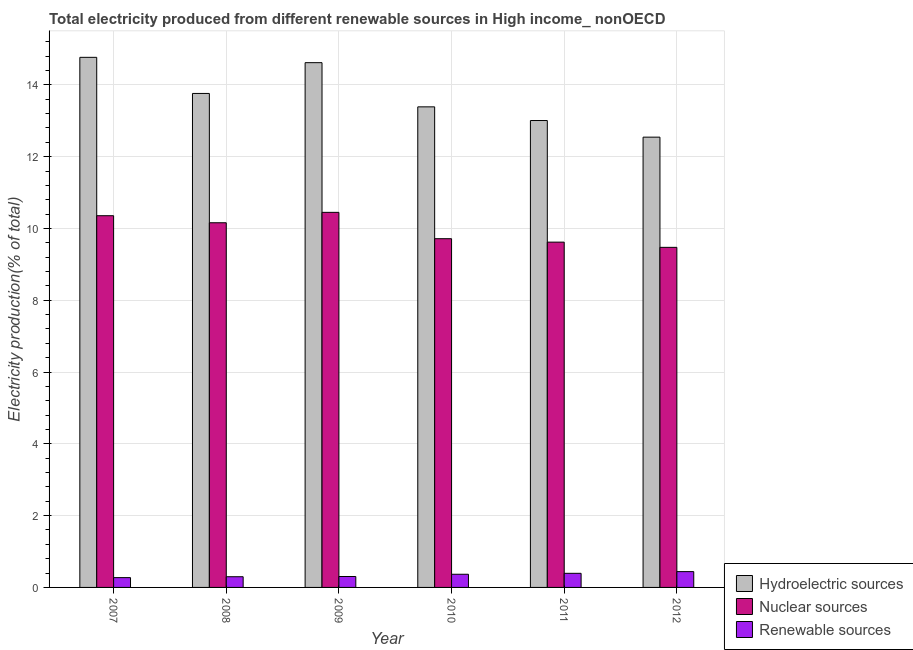How many different coloured bars are there?
Give a very brief answer. 3. How many groups of bars are there?
Provide a succinct answer. 6. Are the number of bars per tick equal to the number of legend labels?
Provide a short and direct response. Yes. How many bars are there on the 6th tick from the right?
Provide a short and direct response. 3. What is the label of the 6th group of bars from the left?
Offer a very short reply. 2012. In how many cases, is the number of bars for a given year not equal to the number of legend labels?
Provide a short and direct response. 0. What is the percentage of electricity produced by hydroelectric sources in 2012?
Offer a terse response. 12.54. Across all years, what is the maximum percentage of electricity produced by hydroelectric sources?
Offer a very short reply. 14.77. Across all years, what is the minimum percentage of electricity produced by nuclear sources?
Ensure brevity in your answer.  9.47. In which year was the percentage of electricity produced by hydroelectric sources minimum?
Ensure brevity in your answer.  2012. What is the total percentage of electricity produced by hydroelectric sources in the graph?
Provide a short and direct response. 82.09. What is the difference between the percentage of electricity produced by renewable sources in 2008 and that in 2009?
Your response must be concise. -0.01. What is the difference between the percentage of electricity produced by hydroelectric sources in 2007 and the percentage of electricity produced by renewable sources in 2009?
Your answer should be very brief. 0.15. What is the average percentage of electricity produced by nuclear sources per year?
Your answer should be very brief. 9.96. What is the ratio of the percentage of electricity produced by hydroelectric sources in 2009 to that in 2012?
Offer a very short reply. 1.17. Is the percentage of electricity produced by nuclear sources in 2009 less than that in 2011?
Make the answer very short. No. Is the difference between the percentage of electricity produced by renewable sources in 2008 and 2010 greater than the difference between the percentage of electricity produced by hydroelectric sources in 2008 and 2010?
Provide a short and direct response. No. What is the difference between the highest and the second highest percentage of electricity produced by hydroelectric sources?
Offer a very short reply. 0.15. What is the difference between the highest and the lowest percentage of electricity produced by nuclear sources?
Your response must be concise. 0.97. What does the 1st bar from the left in 2009 represents?
Give a very brief answer. Hydroelectric sources. What does the 1st bar from the right in 2012 represents?
Make the answer very short. Renewable sources. How many bars are there?
Provide a succinct answer. 18. Are the values on the major ticks of Y-axis written in scientific E-notation?
Your answer should be compact. No. How many legend labels are there?
Provide a succinct answer. 3. What is the title of the graph?
Your answer should be compact. Total electricity produced from different renewable sources in High income_ nonOECD. What is the label or title of the X-axis?
Give a very brief answer. Year. What is the label or title of the Y-axis?
Keep it short and to the point. Electricity production(% of total). What is the Electricity production(% of total) in Hydroelectric sources in 2007?
Provide a succinct answer. 14.77. What is the Electricity production(% of total) in Nuclear sources in 2007?
Your response must be concise. 10.36. What is the Electricity production(% of total) of Renewable sources in 2007?
Offer a very short reply. 0.27. What is the Electricity production(% of total) in Hydroelectric sources in 2008?
Give a very brief answer. 13.76. What is the Electricity production(% of total) in Nuclear sources in 2008?
Keep it short and to the point. 10.16. What is the Electricity production(% of total) of Renewable sources in 2008?
Offer a very short reply. 0.3. What is the Electricity production(% of total) of Hydroelectric sources in 2009?
Your answer should be compact. 14.62. What is the Electricity production(% of total) in Nuclear sources in 2009?
Provide a short and direct response. 10.45. What is the Electricity production(% of total) in Renewable sources in 2009?
Provide a short and direct response. 0.3. What is the Electricity production(% of total) of Hydroelectric sources in 2010?
Offer a very short reply. 13.39. What is the Electricity production(% of total) of Nuclear sources in 2010?
Provide a short and direct response. 9.71. What is the Electricity production(% of total) in Renewable sources in 2010?
Make the answer very short. 0.37. What is the Electricity production(% of total) of Hydroelectric sources in 2011?
Keep it short and to the point. 13.01. What is the Electricity production(% of total) in Nuclear sources in 2011?
Keep it short and to the point. 9.62. What is the Electricity production(% of total) of Renewable sources in 2011?
Provide a succinct answer. 0.39. What is the Electricity production(% of total) of Hydroelectric sources in 2012?
Keep it short and to the point. 12.54. What is the Electricity production(% of total) in Nuclear sources in 2012?
Offer a terse response. 9.47. What is the Electricity production(% of total) in Renewable sources in 2012?
Provide a short and direct response. 0.44. Across all years, what is the maximum Electricity production(% of total) of Hydroelectric sources?
Provide a succinct answer. 14.77. Across all years, what is the maximum Electricity production(% of total) of Nuclear sources?
Provide a succinct answer. 10.45. Across all years, what is the maximum Electricity production(% of total) in Renewable sources?
Offer a terse response. 0.44. Across all years, what is the minimum Electricity production(% of total) in Hydroelectric sources?
Your answer should be compact. 12.54. Across all years, what is the minimum Electricity production(% of total) of Nuclear sources?
Your answer should be very brief. 9.47. Across all years, what is the minimum Electricity production(% of total) of Renewable sources?
Offer a very short reply. 0.27. What is the total Electricity production(% of total) in Hydroelectric sources in the graph?
Your answer should be very brief. 82.09. What is the total Electricity production(% of total) of Nuclear sources in the graph?
Provide a short and direct response. 59.77. What is the total Electricity production(% of total) in Renewable sources in the graph?
Offer a terse response. 2.08. What is the difference between the Electricity production(% of total) of Hydroelectric sources in 2007 and that in 2008?
Ensure brevity in your answer.  1.01. What is the difference between the Electricity production(% of total) in Nuclear sources in 2007 and that in 2008?
Keep it short and to the point. 0.2. What is the difference between the Electricity production(% of total) of Renewable sources in 2007 and that in 2008?
Ensure brevity in your answer.  -0.02. What is the difference between the Electricity production(% of total) in Hydroelectric sources in 2007 and that in 2009?
Your response must be concise. 0.15. What is the difference between the Electricity production(% of total) in Nuclear sources in 2007 and that in 2009?
Provide a succinct answer. -0.09. What is the difference between the Electricity production(% of total) of Renewable sources in 2007 and that in 2009?
Make the answer very short. -0.03. What is the difference between the Electricity production(% of total) in Hydroelectric sources in 2007 and that in 2010?
Your response must be concise. 1.38. What is the difference between the Electricity production(% of total) of Nuclear sources in 2007 and that in 2010?
Give a very brief answer. 0.64. What is the difference between the Electricity production(% of total) in Renewable sources in 2007 and that in 2010?
Make the answer very short. -0.09. What is the difference between the Electricity production(% of total) in Hydroelectric sources in 2007 and that in 2011?
Make the answer very short. 1.76. What is the difference between the Electricity production(% of total) of Nuclear sources in 2007 and that in 2011?
Provide a succinct answer. 0.74. What is the difference between the Electricity production(% of total) of Renewable sources in 2007 and that in 2011?
Your response must be concise. -0.12. What is the difference between the Electricity production(% of total) in Hydroelectric sources in 2007 and that in 2012?
Give a very brief answer. 2.22. What is the difference between the Electricity production(% of total) of Nuclear sources in 2007 and that in 2012?
Your answer should be very brief. 0.88. What is the difference between the Electricity production(% of total) of Renewable sources in 2007 and that in 2012?
Make the answer very short. -0.17. What is the difference between the Electricity production(% of total) in Hydroelectric sources in 2008 and that in 2009?
Your response must be concise. -0.86. What is the difference between the Electricity production(% of total) in Nuclear sources in 2008 and that in 2009?
Keep it short and to the point. -0.29. What is the difference between the Electricity production(% of total) in Renewable sources in 2008 and that in 2009?
Ensure brevity in your answer.  -0.01. What is the difference between the Electricity production(% of total) of Hydroelectric sources in 2008 and that in 2010?
Make the answer very short. 0.37. What is the difference between the Electricity production(% of total) in Nuclear sources in 2008 and that in 2010?
Your answer should be very brief. 0.44. What is the difference between the Electricity production(% of total) in Renewable sources in 2008 and that in 2010?
Offer a very short reply. -0.07. What is the difference between the Electricity production(% of total) in Hydroelectric sources in 2008 and that in 2011?
Offer a terse response. 0.75. What is the difference between the Electricity production(% of total) of Nuclear sources in 2008 and that in 2011?
Your response must be concise. 0.54. What is the difference between the Electricity production(% of total) in Renewable sources in 2008 and that in 2011?
Provide a succinct answer. -0.09. What is the difference between the Electricity production(% of total) in Hydroelectric sources in 2008 and that in 2012?
Ensure brevity in your answer.  1.22. What is the difference between the Electricity production(% of total) in Nuclear sources in 2008 and that in 2012?
Your answer should be compact. 0.69. What is the difference between the Electricity production(% of total) of Renewable sources in 2008 and that in 2012?
Your answer should be very brief. -0.14. What is the difference between the Electricity production(% of total) of Hydroelectric sources in 2009 and that in 2010?
Provide a succinct answer. 1.23. What is the difference between the Electricity production(% of total) in Nuclear sources in 2009 and that in 2010?
Give a very brief answer. 0.73. What is the difference between the Electricity production(% of total) in Renewable sources in 2009 and that in 2010?
Provide a succinct answer. -0.06. What is the difference between the Electricity production(% of total) in Hydroelectric sources in 2009 and that in 2011?
Your answer should be compact. 1.61. What is the difference between the Electricity production(% of total) of Nuclear sources in 2009 and that in 2011?
Your response must be concise. 0.83. What is the difference between the Electricity production(% of total) of Renewable sources in 2009 and that in 2011?
Offer a very short reply. -0.09. What is the difference between the Electricity production(% of total) in Hydroelectric sources in 2009 and that in 2012?
Offer a terse response. 2.08. What is the difference between the Electricity production(% of total) of Renewable sources in 2009 and that in 2012?
Give a very brief answer. -0.14. What is the difference between the Electricity production(% of total) in Hydroelectric sources in 2010 and that in 2011?
Your response must be concise. 0.38. What is the difference between the Electricity production(% of total) of Nuclear sources in 2010 and that in 2011?
Your response must be concise. 0.1. What is the difference between the Electricity production(% of total) of Renewable sources in 2010 and that in 2011?
Keep it short and to the point. -0.03. What is the difference between the Electricity production(% of total) in Hydroelectric sources in 2010 and that in 2012?
Give a very brief answer. 0.84. What is the difference between the Electricity production(% of total) in Nuclear sources in 2010 and that in 2012?
Offer a very short reply. 0.24. What is the difference between the Electricity production(% of total) in Renewable sources in 2010 and that in 2012?
Ensure brevity in your answer.  -0.07. What is the difference between the Electricity production(% of total) in Hydroelectric sources in 2011 and that in 2012?
Make the answer very short. 0.46. What is the difference between the Electricity production(% of total) of Nuclear sources in 2011 and that in 2012?
Your answer should be very brief. 0.15. What is the difference between the Electricity production(% of total) of Renewable sources in 2011 and that in 2012?
Your answer should be very brief. -0.05. What is the difference between the Electricity production(% of total) in Hydroelectric sources in 2007 and the Electricity production(% of total) in Nuclear sources in 2008?
Provide a short and direct response. 4.61. What is the difference between the Electricity production(% of total) in Hydroelectric sources in 2007 and the Electricity production(% of total) in Renewable sources in 2008?
Your answer should be very brief. 14.47. What is the difference between the Electricity production(% of total) of Nuclear sources in 2007 and the Electricity production(% of total) of Renewable sources in 2008?
Give a very brief answer. 10.06. What is the difference between the Electricity production(% of total) in Hydroelectric sources in 2007 and the Electricity production(% of total) in Nuclear sources in 2009?
Ensure brevity in your answer.  4.32. What is the difference between the Electricity production(% of total) of Hydroelectric sources in 2007 and the Electricity production(% of total) of Renewable sources in 2009?
Your answer should be compact. 14.46. What is the difference between the Electricity production(% of total) in Nuclear sources in 2007 and the Electricity production(% of total) in Renewable sources in 2009?
Provide a succinct answer. 10.05. What is the difference between the Electricity production(% of total) in Hydroelectric sources in 2007 and the Electricity production(% of total) in Nuclear sources in 2010?
Your answer should be compact. 5.05. What is the difference between the Electricity production(% of total) of Hydroelectric sources in 2007 and the Electricity production(% of total) of Renewable sources in 2010?
Your answer should be compact. 14.4. What is the difference between the Electricity production(% of total) of Nuclear sources in 2007 and the Electricity production(% of total) of Renewable sources in 2010?
Your response must be concise. 9.99. What is the difference between the Electricity production(% of total) of Hydroelectric sources in 2007 and the Electricity production(% of total) of Nuclear sources in 2011?
Provide a succinct answer. 5.15. What is the difference between the Electricity production(% of total) in Hydroelectric sources in 2007 and the Electricity production(% of total) in Renewable sources in 2011?
Make the answer very short. 14.37. What is the difference between the Electricity production(% of total) in Nuclear sources in 2007 and the Electricity production(% of total) in Renewable sources in 2011?
Provide a succinct answer. 9.96. What is the difference between the Electricity production(% of total) of Hydroelectric sources in 2007 and the Electricity production(% of total) of Nuclear sources in 2012?
Give a very brief answer. 5.29. What is the difference between the Electricity production(% of total) in Hydroelectric sources in 2007 and the Electricity production(% of total) in Renewable sources in 2012?
Keep it short and to the point. 14.33. What is the difference between the Electricity production(% of total) of Nuclear sources in 2007 and the Electricity production(% of total) of Renewable sources in 2012?
Ensure brevity in your answer.  9.91. What is the difference between the Electricity production(% of total) in Hydroelectric sources in 2008 and the Electricity production(% of total) in Nuclear sources in 2009?
Offer a very short reply. 3.31. What is the difference between the Electricity production(% of total) in Hydroelectric sources in 2008 and the Electricity production(% of total) in Renewable sources in 2009?
Give a very brief answer. 13.46. What is the difference between the Electricity production(% of total) in Nuclear sources in 2008 and the Electricity production(% of total) in Renewable sources in 2009?
Keep it short and to the point. 9.85. What is the difference between the Electricity production(% of total) in Hydroelectric sources in 2008 and the Electricity production(% of total) in Nuclear sources in 2010?
Offer a very short reply. 4.05. What is the difference between the Electricity production(% of total) in Hydroelectric sources in 2008 and the Electricity production(% of total) in Renewable sources in 2010?
Your response must be concise. 13.39. What is the difference between the Electricity production(% of total) in Nuclear sources in 2008 and the Electricity production(% of total) in Renewable sources in 2010?
Your answer should be very brief. 9.79. What is the difference between the Electricity production(% of total) of Hydroelectric sources in 2008 and the Electricity production(% of total) of Nuclear sources in 2011?
Your answer should be very brief. 4.14. What is the difference between the Electricity production(% of total) of Hydroelectric sources in 2008 and the Electricity production(% of total) of Renewable sources in 2011?
Make the answer very short. 13.37. What is the difference between the Electricity production(% of total) in Nuclear sources in 2008 and the Electricity production(% of total) in Renewable sources in 2011?
Ensure brevity in your answer.  9.77. What is the difference between the Electricity production(% of total) in Hydroelectric sources in 2008 and the Electricity production(% of total) in Nuclear sources in 2012?
Offer a terse response. 4.29. What is the difference between the Electricity production(% of total) of Hydroelectric sources in 2008 and the Electricity production(% of total) of Renewable sources in 2012?
Ensure brevity in your answer.  13.32. What is the difference between the Electricity production(% of total) of Nuclear sources in 2008 and the Electricity production(% of total) of Renewable sources in 2012?
Your answer should be compact. 9.72. What is the difference between the Electricity production(% of total) of Hydroelectric sources in 2009 and the Electricity production(% of total) of Nuclear sources in 2010?
Offer a terse response. 4.9. What is the difference between the Electricity production(% of total) of Hydroelectric sources in 2009 and the Electricity production(% of total) of Renewable sources in 2010?
Offer a terse response. 14.25. What is the difference between the Electricity production(% of total) in Nuclear sources in 2009 and the Electricity production(% of total) in Renewable sources in 2010?
Your answer should be very brief. 10.08. What is the difference between the Electricity production(% of total) of Hydroelectric sources in 2009 and the Electricity production(% of total) of Nuclear sources in 2011?
Offer a very short reply. 5. What is the difference between the Electricity production(% of total) of Hydroelectric sources in 2009 and the Electricity production(% of total) of Renewable sources in 2011?
Provide a succinct answer. 14.23. What is the difference between the Electricity production(% of total) of Nuclear sources in 2009 and the Electricity production(% of total) of Renewable sources in 2011?
Your response must be concise. 10.06. What is the difference between the Electricity production(% of total) of Hydroelectric sources in 2009 and the Electricity production(% of total) of Nuclear sources in 2012?
Provide a succinct answer. 5.14. What is the difference between the Electricity production(% of total) of Hydroelectric sources in 2009 and the Electricity production(% of total) of Renewable sources in 2012?
Your response must be concise. 14.18. What is the difference between the Electricity production(% of total) in Nuclear sources in 2009 and the Electricity production(% of total) in Renewable sources in 2012?
Provide a succinct answer. 10.01. What is the difference between the Electricity production(% of total) of Hydroelectric sources in 2010 and the Electricity production(% of total) of Nuclear sources in 2011?
Provide a succinct answer. 3.77. What is the difference between the Electricity production(% of total) of Hydroelectric sources in 2010 and the Electricity production(% of total) of Renewable sources in 2011?
Give a very brief answer. 13. What is the difference between the Electricity production(% of total) of Nuclear sources in 2010 and the Electricity production(% of total) of Renewable sources in 2011?
Ensure brevity in your answer.  9.32. What is the difference between the Electricity production(% of total) in Hydroelectric sources in 2010 and the Electricity production(% of total) in Nuclear sources in 2012?
Offer a very short reply. 3.91. What is the difference between the Electricity production(% of total) in Hydroelectric sources in 2010 and the Electricity production(% of total) in Renewable sources in 2012?
Your answer should be compact. 12.95. What is the difference between the Electricity production(% of total) in Nuclear sources in 2010 and the Electricity production(% of total) in Renewable sources in 2012?
Keep it short and to the point. 9.27. What is the difference between the Electricity production(% of total) of Hydroelectric sources in 2011 and the Electricity production(% of total) of Nuclear sources in 2012?
Your answer should be very brief. 3.53. What is the difference between the Electricity production(% of total) of Hydroelectric sources in 2011 and the Electricity production(% of total) of Renewable sources in 2012?
Provide a succinct answer. 12.57. What is the difference between the Electricity production(% of total) of Nuclear sources in 2011 and the Electricity production(% of total) of Renewable sources in 2012?
Your answer should be very brief. 9.18. What is the average Electricity production(% of total) in Hydroelectric sources per year?
Keep it short and to the point. 13.68. What is the average Electricity production(% of total) of Nuclear sources per year?
Give a very brief answer. 9.96. What is the average Electricity production(% of total) in Renewable sources per year?
Make the answer very short. 0.35. In the year 2007, what is the difference between the Electricity production(% of total) in Hydroelectric sources and Electricity production(% of total) in Nuclear sources?
Give a very brief answer. 4.41. In the year 2007, what is the difference between the Electricity production(% of total) of Hydroelectric sources and Electricity production(% of total) of Renewable sources?
Your answer should be compact. 14.49. In the year 2007, what is the difference between the Electricity production(% of total) of Nuclear sources and Electricity production(% of total) of Renewable sources?
Offer a very short reply. 10.08. In the year 2008, what is the difference between the Electricity production(% of total) of Hydroelectric sources and Electricity production(% of total) of Nuclear sources?
Ensure brevity in your answer.  3.6. In the year 2008, what is the difference between the Electricity production(% of total) in Hydroelectric sources and Electricity production(% of total) in Renewable sources?
Ensure brevity in your answer.  13.46. In the year 2008, what is the difference between the Electricity production(% of total) of Nuclear sources and Electricity production(% of total) of Renewable sources?
Offer a terse response. 9.86. In the year 2009, what is the difference between the Electricity production(% of total) of Hydroelectric sources and Electricity production(% of total) of Nuclear sources?
Keep it short and to the point. 4.17. In the year 2009, what is the difference between the Electricity production(% of total) in Hydroelectric sources and Electricity production(% of total) in Renewable sources?
Your answer should be very brief. 14.31. In the year 2009, what is the difference between the Electricity production(% of total) in Nuclear sources and Electricity production(% of total) in Renewable sources?
Keep it short and to the point. 10.14. In the year 2010, what is the difference between the Electricity production(% of total) of Hydroelectric sources and Electricity production(% of total) of Nuclear sources?
Your answer should be very brief. 3.67. In the year 2010, what is the difference between the Electricity production(% of total) of Hydroelectric sources and Electricity production(% of total) of Renewable sources?
Provide a succinct answer. 13.02. In the year 2010, what is the difference between the Electricity production(% of total) of Nuclear sources and Electricity production(% of total) of Renewable sources?
Give a very brief answer. 9.35. In the year 2011, what is the difference between the Electricity production(% of total) of Hydroelectric sources and Electricity production(% of total) of Nuclear sources?
Your response must be concise. 3.39. In the year 2011, what is the difference between the Electricity production(% of total) of Hydroelectric sources and Electricity production(% of total) of Renewable sources?
Make the answer very short. 12.61. In the year 2011, what is the difference between the Electricity production(% of total) of Nuclear sources and Electricity production(% of total) of Renewable sources?
Offer a terse response. 9.23. In the year 2012, what is the difference between the Electricity production(% of total) of Hydroelectric sources and Electricity production(% of total) of Nuclear sources?
Your answer should be compact. 3.07. In the year 2012, what is the difference between the Electricity production(% of total) of Hydroelectric sources and Electricity production(% of total) of Renewable sources?
Your response must be concise. 12.1. In the year 2012, what is the difference between the Electricity production(% of total) of Nuclear sources and Electricity production(% of total) of Renewable sources?
Your response must be concise. 9.03. What is the ratio of the Electricity production(% of total) in Hydroelectric sources in 2007 to that in 2008?
Make the answer very short. 1.07. What is the ratio of the Electricity production(% of total) in Nuclear sources in 2007 to that in 2008?
Keep it short and to the point. 1.02. What is the ratio of the Electricity production(% of total) in Renewable sources in 2007 to that in 2008?
Provide a short and direct response. 0.92. What is the ratio of the Electricity production(% of total) of Hydroelectric sources in 2007 to that in 2009?
Provide a short and direct response. 1.01. What is the ratio of the Electricity production(% of total) of Nuclear sources in 2007 to that in 2009?
Provide a short and direct response. 0.99. What is the ratio of the Electricity production(% of total) in Renewable sources in 2007 to that in 2009?
Offer a terse response. 0.9. What is the ratio of the Electricity production(% of total) in Hydroelectric sources in 2007 to that in 2010?
Offer a very short reply. 1.1. What is the ratio of the Electricity production(% of total) in Nuclear sources in 2007 to that in 2010?
Offer a very short reply. 1.07. What is the ratio of the Electricity production(% of total) in Renewable sources in 2007 to that in 2010?
Provide a succinct answer. 0.74. What is the ratio of the Electricity production(% of total) of Hydroelectric sources in 2007 to that in 2011?
Provide a succinct answer. 1.14. What is the ratio of the Electricity production(% of total) in Nuclear sources in 2007 to that in 2011?
Your answer should be compact. 1.08. What is the ratio of the Electricity production(% of total) of Renewable sources in 2007 to that in 2011?
Ensure brevity in your answer.  0.7. What is the ratio of the Electricity production(% of total) of Hydroelectric sources in 2007 to that in 2012?
Provide a short and direct response. 1.18. What is the ratio of the Electricity production(% of total) of Nuclear sources in 2007 to that in 2012?
Your response must be concise. 1.09. What is the ratio of the Electricity production(% of total) of Renewable sources in 2007 to that in 2012?
Ensure brevity in your answer.  0.62. What is the ratio of the Electricity production(% of total) in Hydroelectric sources in 2008 to that in 2009?
Keep it short and to the point. 0.94. What is the ratio of the Electricity production(% of total) of Nuclear sources in 2008 to that in 2009?
Make the answer very short. 0.97. What is the ratio of the Electricity production(% of total) in Renewable sources in 2008 to that in 2009?
Your answer should be compact. 0.98. What is the ratio of the Electricity production(% of total) of Hydroelectric sources in 2008 to that in 2010?
Your response must be concise. 1.03. What is the ratio of the Electricity production(% of total) in Nuclear sources in 2008 to that in 2010?
Your answer should be very brief. 1.05. What is the ratio of the Electricity production(% of total) of Renewable sources in 2008 to that in 2010?
Offer a very short reply. 0.81. What is the ratio of the Electricity production(% of total) of Hydroelectric sources in 2008 to that in 2011?
Keep it short and to the point. 1.06. What is the ratio of the Electricity production(% of total) in Nuclear sources in 2008 to that in 2011?
Provide a short and direct response. 1.06. What is the ratio of the Electricity production(% of total) of Renewable sources in 2008 to that in 2011?
Make the answer very short. 0.76. What is the ratio of the Electricity production(% of total) in Hydroelectric sources in 2008 to that in 2012?
Make the answer very short. 1.1. What is the ratio of the Electricity production(% of total) of Nuclear sources in 2008 to that in 2012?
Offer a very short reply. 1.07. What is the ratio of the Electricity production(% of total) in Renewable sources in 2008 to that in 2012?
Your answer should be compact. 0.68. What is the ratio of the Electricity production(% of total) in Hydroelectric sources in 2009 to that in 2010?
Keep it short and to the point. 1.09. What is the ratio of the Electricity production(% of total) in Nuclear sources in 2009 to that in 2010?
Provide a succinct answer. 1.08. What is the ratio of the Electricity production(% of total) in Renewable sources in 2009 to that in 2010?
Keep it short and to the point. 0.83. What is the ratio of the Electricity production(% of total) in Hydroelectric sources in 2009 to that in 2011?
Offer a very short reply. 1.12. What is the ratio of the Electricity production(% of total) of Nuclear sources in 2009 to that in 2011?
Your response must be concise. 1.09. What is the ratio of the Electricity production(% of total) of Renewable sources in 2009 to that in 2011?
Your answer should be compact. 0.77. What is the ratio of the Electricity production(% of total) in Hydroelectric sources in 2009 to that in 2012?
Ensure brevity in your answer.  1.17. What is the ratio of the Electricity production(% of total) of Nuclear sources in 2009 to that in 2012?
Your answer should be very brief. 1.1. What is the ratio of the Electricity production(% of total) of Renewable sources in 2009 to that in 2012?
Offer a very short reply. 0.69. What is the ratio of the Electricity production(% of total) in Hydroelectric sources in 2010 to that in 2011?
Give a very brief answer. 1.03. What is the ratio of the Electricity production(% of total) in Nuclear sources in 2010 to that in 2011?
Provide a short and direct response. 1.01. What is the ratio of the Electricity production(% of total) of Renewable sources in 2010 to that in 2011?
Give a very brief answer. 0.93. What is the ratio of the Electricity production(% of total) of Hydroelectric sources in 2010 to that in 2012?
Your answer should be very brief. 1.07. What is the ratio of the Electricity production(% of total) in Nuclear sources in 2010 to that in 2012?
Offer a terse response. 1.03. What is the ratio of the Electricity production(% of total) in Renewable sources in 2010 to that in 2012?
Your answer should be compact. 0.83. What is the ratio of the Electricity production(% of total) of Hydroelectric sources in 2011 to that in 2012?
Provide a succinct answer. 1.04. What is the ratio of the Electricity production(% of total) in Nuclear sources in 2011 to that in 2012?
Offer a very short reply. 1.02. What is the ratio of the Electricity production(% of total) in Renewable sources in 2011 to that in 2012?
Make the answer very short. 0.89. What is the difference between the highest and the second highest Electricity production(% of total) of Hydroelectric sources?
Provide a short and direct response. 0.15. What is the difference between the highest and the second highest Electricity production(% of total) of Nuclear sources?
Provide a short and direct response. 0.09. What is the difference between the highest and the second highest Electricity production(% of total) of Renewable sources?
Ensure brevity in your answer.  0.05. What is the difference between the highest and the lowest Electricity production(% of total) in Hydroelectric sources?
Provide a succinct answer. 2.22. What is the difference between the highest and the lowest Electricity production(% of total) in Nuclear sources?
Your answer should be compact. 0.97. What is the difference between the highest and the lowest Electricity production(% of total) of Renewable sources?
Offer a very short reply. 0.17. 